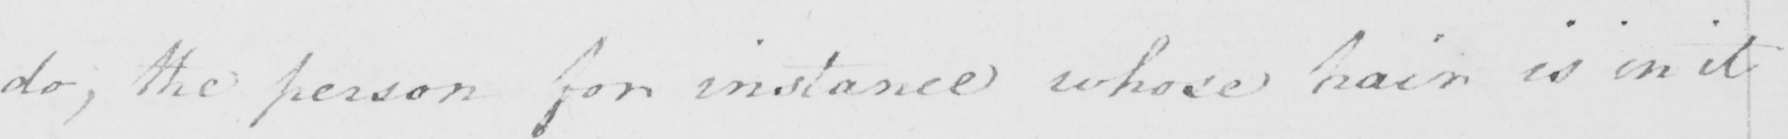Can you tell me what this handwritten text says? do , the person for instance whose hair is in it 